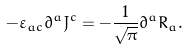<formula> <loc_0><loc_0><loc_500><loc_500>- \varepsilon _ { a c } \partial ^ { a } J ^ { c } = - \frac { 1 } { \sqrt { \pi } } \partial ^ { a } R _ { a } .</formula> 